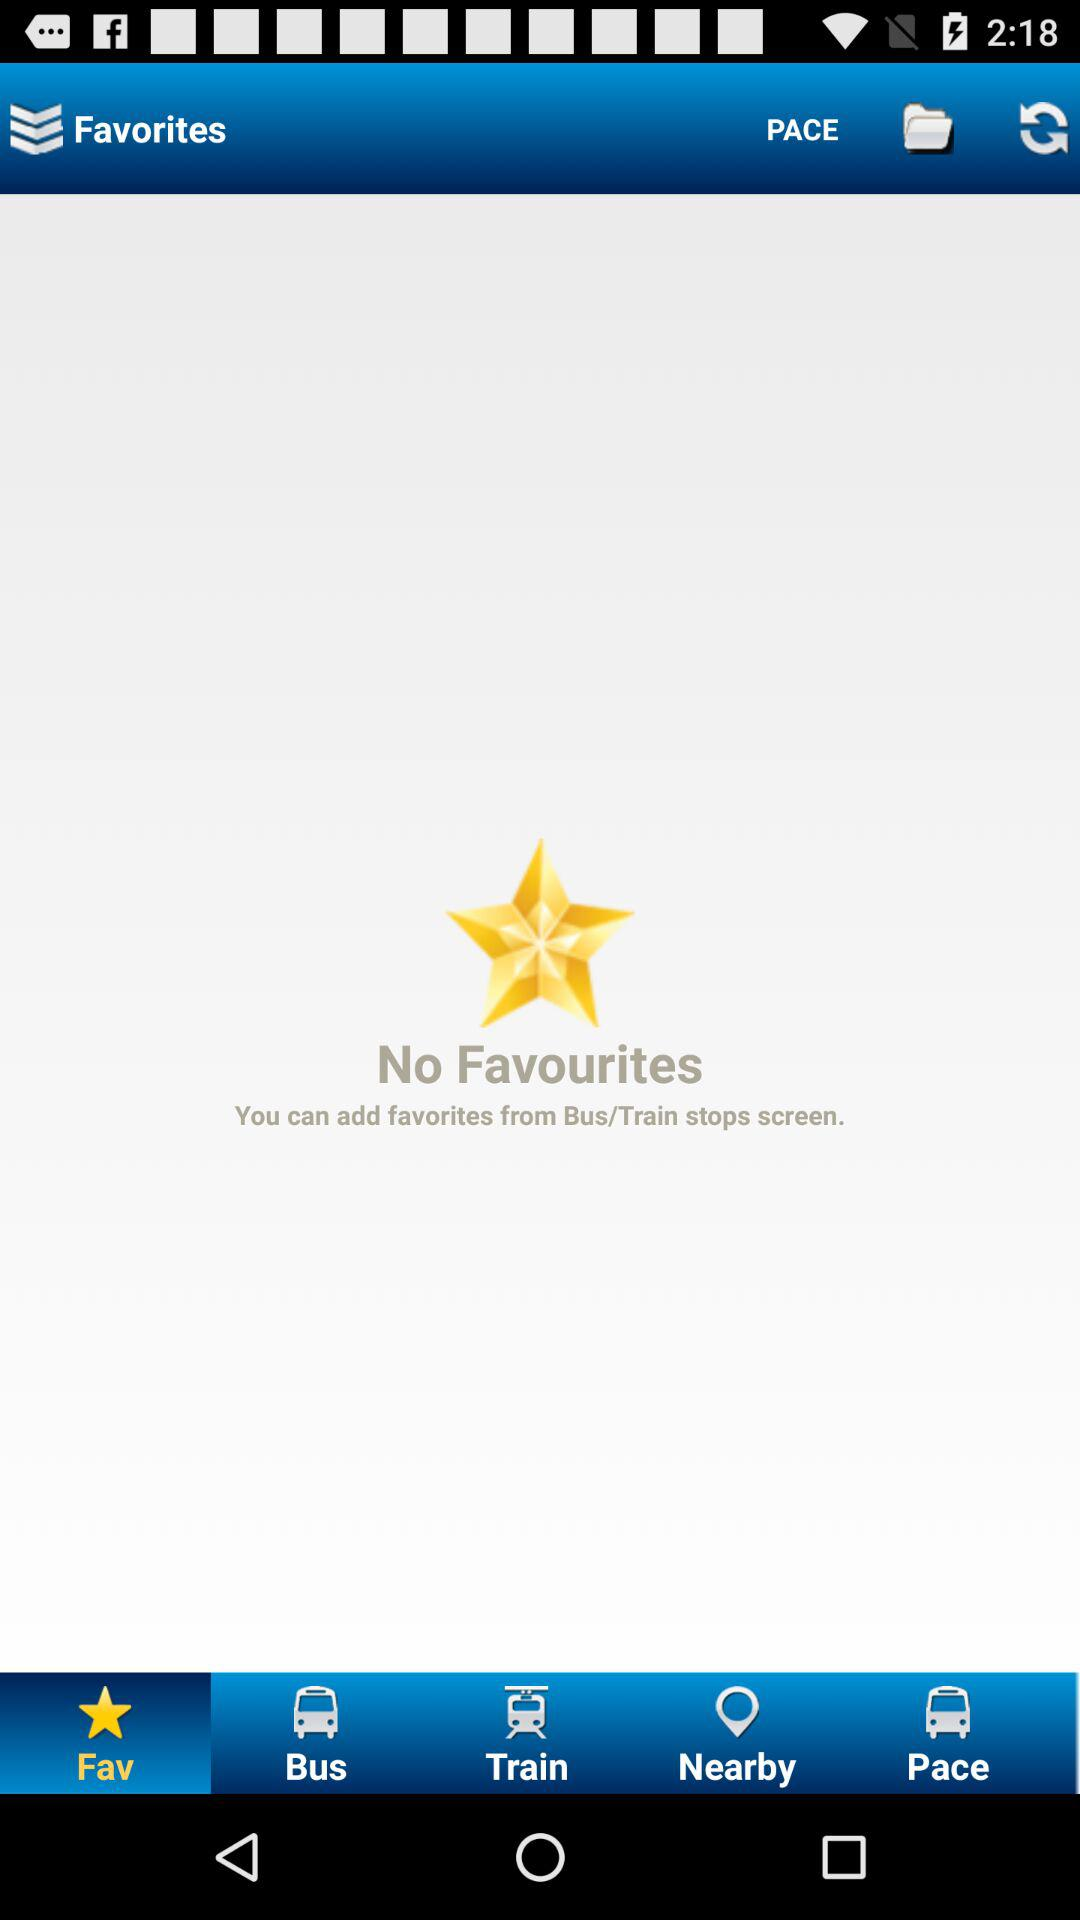Which option is selected? The selected option is "Fav". 